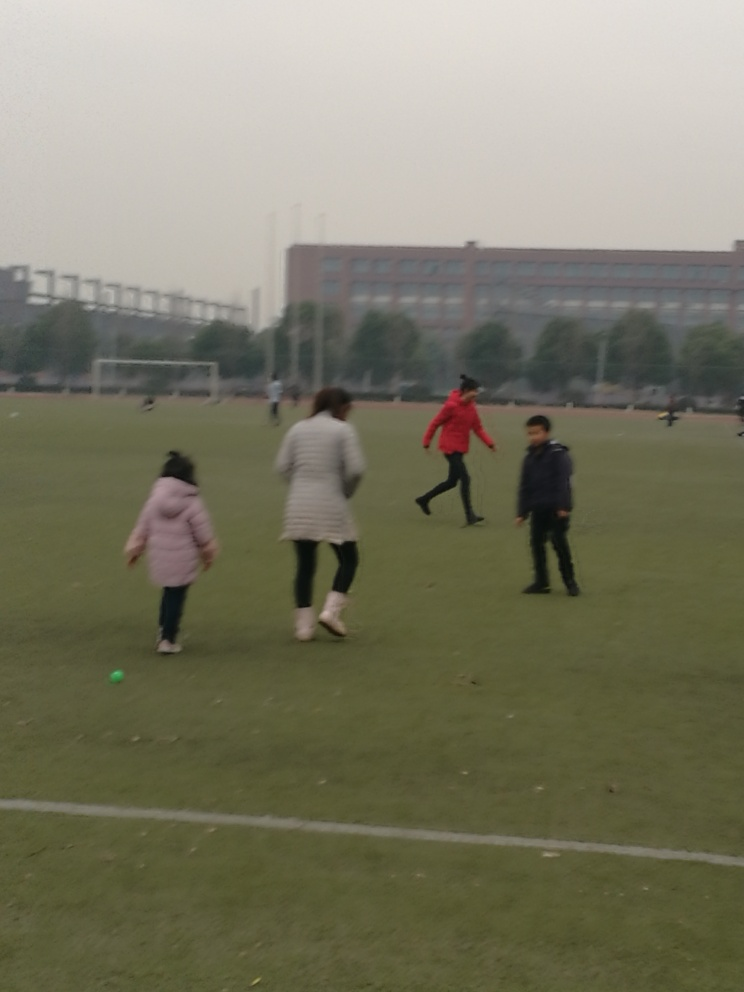Is there any pixelation in the image? The image does display signs of slight blurriness, suggesting a lower resolution or that the image was taken while the subjects were in motion, leading to a less sharp appearance. This might be perceived as pixelation, but technically, it is more akin to motion blur or a focus issue. 